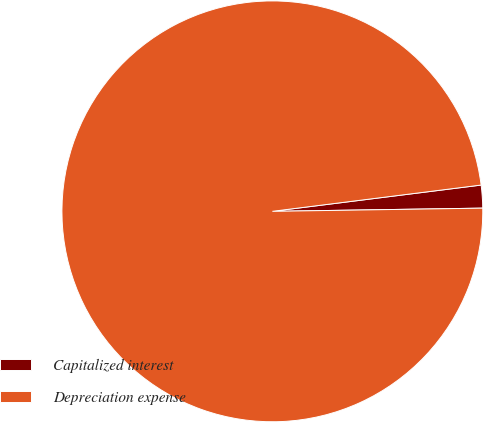<chart> <loc_0><loc_0><loc_500><loc_500><pie_chart><fcel>Capitalized interest<fcel>Depreciation expense<nl><fcel>1.75%<fcel>98.25%<nl></chart> 